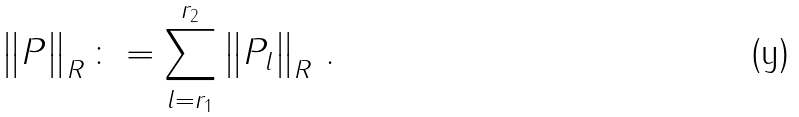<formula> <loc_0><loc_0><loc_500><loc_500>\left \| P \right \| _ { R } \colon = \sum _ { l = r _ { 1 } } ^ { r _ { 2 } } \left \| P _ { l } \right \| _ { R } \, .</formula> 